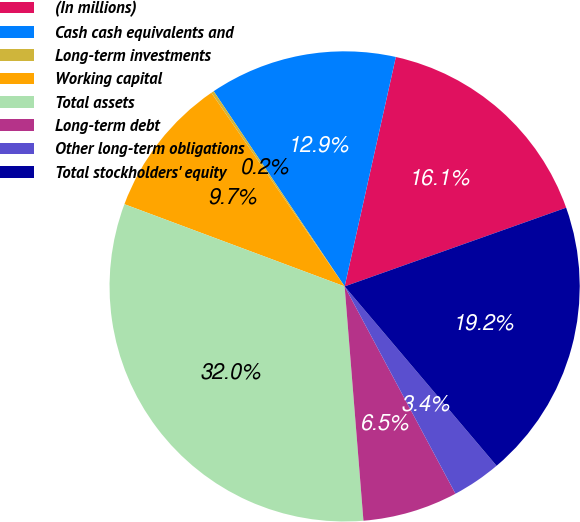<chart> <loc_0><loc_0><loc_500><loc_500><pie_chart><fcel>(In millions)<fcel>Cash cash equivalents and<fcel>Long-term investments<fcel>Working capital<fcel>Total assets<fcel>Long-term debt<fcel>Other long-term obligations<fcel>Total stockholders' equity<nl><fcel>16.07%<fcel>12.9%<fcel>0.19%<fcel>9.72%<fcel>31.96%<fcel>6.54%<fcel>3.37%<fcel>19.25%<nl></chart> 